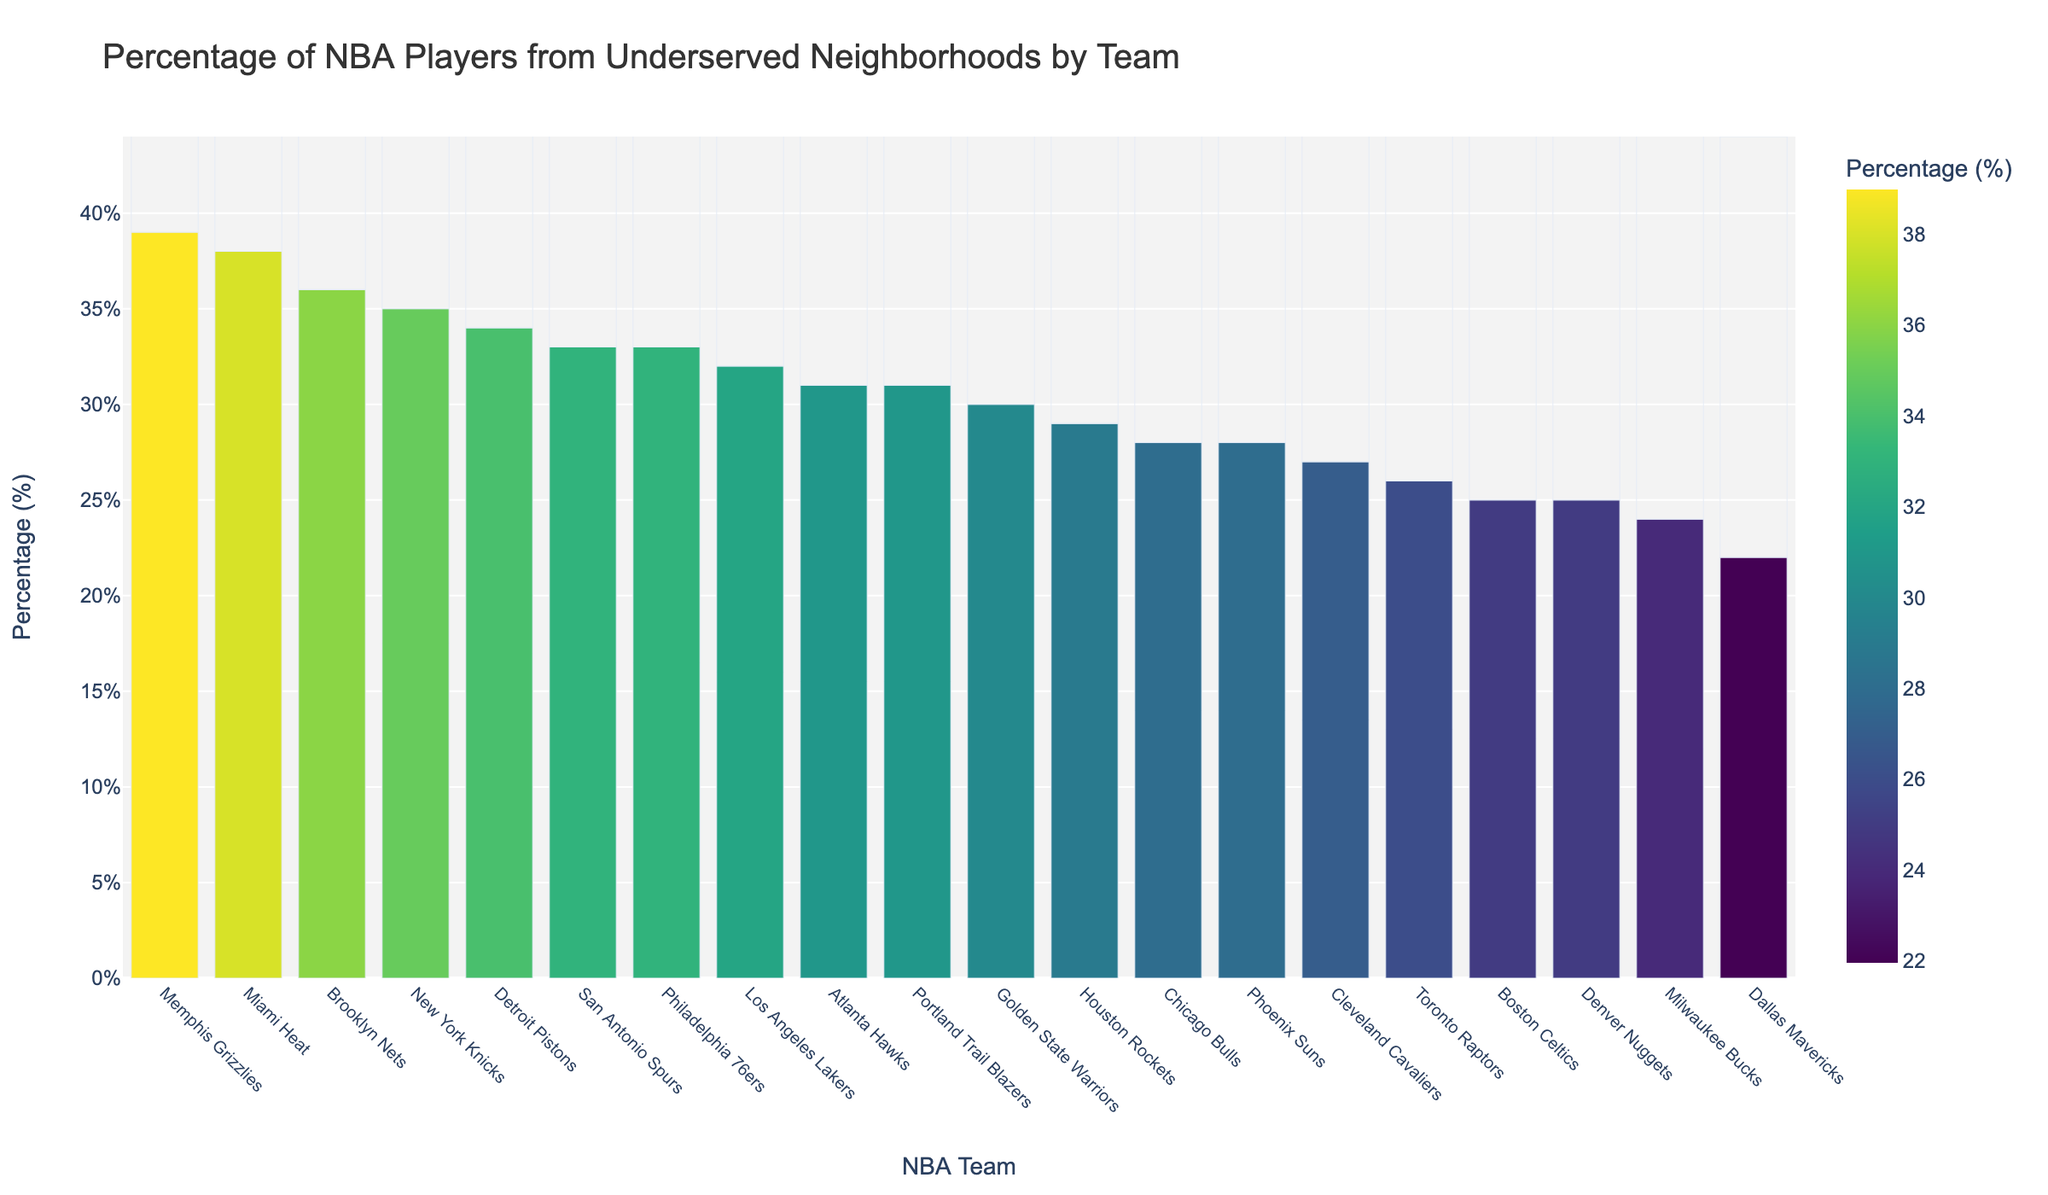Which team has the highest percentage of NBA players from underserved neighborhoods? The chart shows the percentage of NBA players from underserved neighborhoods for each team. The team with the highest bar represents the highest percentage. The Memphis Grizzlies have the highest bar.
Answer: Memphis Grizzlies Which team has the lowest percentage of NBA players from underserved neighborhoods? By looking at the bar chart for the shortest bar, we can identify that the Dallas Mavericks have the lowest percentage.
Answer: Dallas Mavericks What is the percentage difference between the team with the highest percentage and the team with the lowest percentage? The highest percentage is 39% (Memphis Grizzlies) and the lowest is 22% (Dallas Mavericks). To find the difference, subtract 22 from 39. 39% - 22% = 17%
Answer: 17% Which teams have percentages greater than 30%? Looking at the chart, teams with bars extending above the 30% mark are the Memphis Grizzlies, Miami Heat, Brooklyn Nets, New York Knicks, and Philadelphia 76ers.
Answer: Memphis Grizzlies, Miami Heat, Brooklyn Nets, New York Knicks, Philadelphia 76ers Is the percentage of NBA players from underserved neighborhoods higher for the New York Knicks or the Brooklyn Nets? Comparing the heights of the bars for the New York Knicks and the Brooklyn Nets shows that the Brooklyn Nets have a slightly higher percentage.
Answer: Brooklyn Nets What is the average percentage of NBA players from underserved neighborhoods for the top three teams? The top three teams are Memphis Grizzlies (39%), Miami Heat (38%), and Brooklyn Nets (36%). To find the average, add these percentages and divide by 3. (39 + 38 + 36) / 3 = 37.67%
Answer: 37.67% Which team has a percentage closest to the overall average percentage of all the teams? First, calculate the overall average percentage. Sum all percentages (32+28+35+25+30+38+33+29+36+31+34+27+39+26+24+22+28+31+33+25 = 626) and divide by the number of teams (20). The average is 626 / 20 = 31.3%. The Atlanta Hawks (31%) have the percentage closest to this average.
Answer: Atlanta Hawks How many teams have a percentage between 25% and 35%? From the chart, teams with percentages within this range include Los Angeles Lakers (32%), Chicago Bulls (28%), New York Knicks (35%), Boston Celtics (25%), Golden State Warriors (30%), Houston Rockets (29%), Brooklyn Nets (36%), Atlanta Hawks (31%), Detroit Pistons (34%), Cleveland Cavaliers (27%), and Toronto Raptors (26%). Counting these teams gives us 11.
Answer: 11 Which team has a bar that is most similar in height to the Golden State Warriors? Comparing the bar heights visually, the Atlanta Hawks (31%) have a bar that is very close in height to the Golden State Warriors (30%).
Answer: Atlanta Hawks 